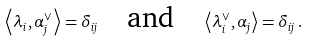Convert formula to latex. <formula><loc_0><loc_0><loc_500><loc_500>\left \langle \lambda _ { i } , \alpha _ { j } ^ { \vee } \right \rangle = \delta _ { i j } \quad \text {and} \quad \left \langle \lambda _ { i } ^ { \vee } , \alpha _ { j } \right \rangle = \delta _ { i j } \, .</formula> 